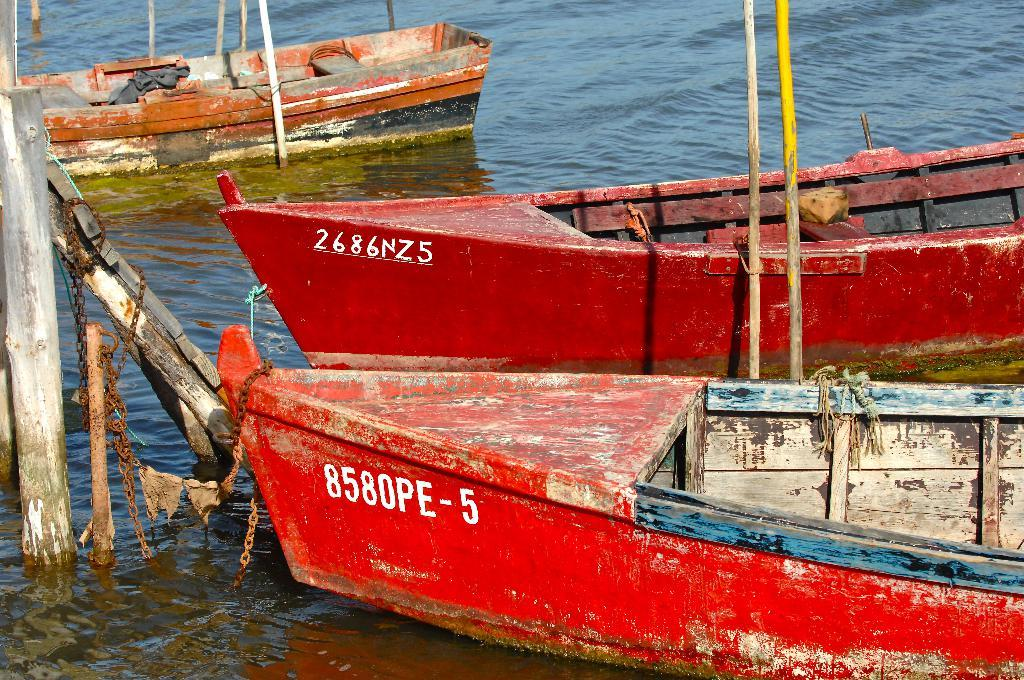What is the main element in the image? There is water in the image. What can be seen floating on the water? There are boats in the image. What colors are the boats? The boats are red and orange in color. Where are the boats located in relation to the water? The boats are on the surface of the water. What other objects are present in the image? There are wooden poles and metal chains in the image. What type of lace can be seen on the band's instruments in the image? There is no band or instruments present in the image; it features water, boats, wooden poles, and metal chains. 